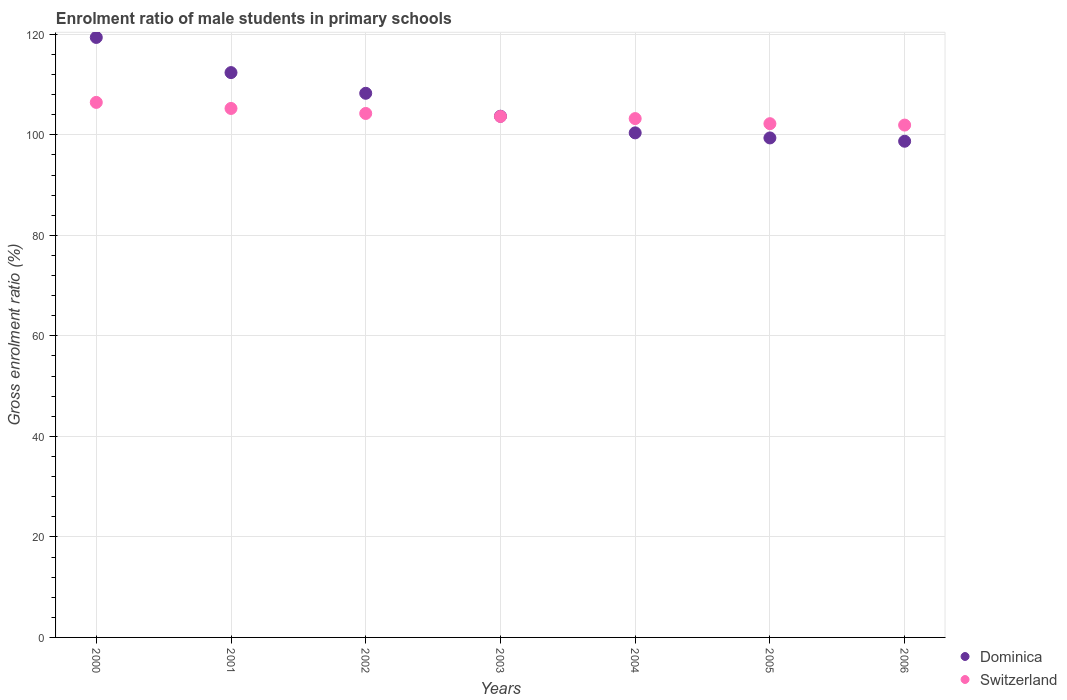How many different coloured dotlines are there?
Make the answer very short. 2. What is the enrolment ratio of male students in primary schools in Dominica in 2002?
Offer a very short reply. 108.27. Across all years, what is the maximum enrolment ratio of male students in primary schools in Dominica?
Make the answer very short. 119.38. Across all years, what is the minimum enrolment ratio of male students in primary schools in Switzerland?
Provide a short and direct response. 101.94. In which year was the enrolment ratio of male students in primary schools in Dominica minimum?
Ensure brevity in your answer.  2006. What is the total enrolment ratio of male students in primary schools in Switzerland in the graph?
Make the answer very short. 727.02. What is the difference between the enrolment ratio of male students in primary schools in Switzerland in 2001 and that in 2004?
Keep it short and to the point. 2.02. What is the difference between the enrolment ratio of male students in primary schools in Dominica in 2002 and the enrolment ratio of male students in primary schools in Switzerland in 2000?
Give a very brief answer. 1.81. What is the average enrolment ratio of male students in primary schools in Dominica per year?
Provide a succinct answer. 106.03. In the year 2003, what is the difference between the enrolment ratio of male students in primary schools in Dominica and enrolment ratio of male students in primary schools in Switzerland?
Provide a short and direct response. 0.04. In how many years, is the enrolment ratio of male students in primary schools in Dominica greater than 8 %?
Provide a succinct answer. 7. What is the ratio of the enrolment ratio of male students in primary schools in Switzerland in 2003 to that in 2004?
Offer a very short reply. 1. What is the difference between the highest and the second highest enrolment ratio of male students in primary schools in Dominica?
Offer a very short reply. 7. What is the difference between the highest and the lowest enrolment ratio of male students in primary schools in Dominica?
Give a very brief answer. 20.65. In how many years, is the enrolment ratio of male students in primary schools in Switzerland greater than the average enrolment ratio of male students in primary schools in Switzerland taken over all years?
Provide a short and direct response. 3. How many years are there in the graph?
Give a very brief answer. 7. Are the values on the major ticks of Y-axis written in scientific E-notation?
Ensure brevity in your answer.  No. Does the graph contain any zero values?
Your response must be concise. No. Where does the legend appear in the graph?
Your answer should be very brief. Bottom right. How many legend labels are there?
Give a very brief answer. 2. How are the legend labels stacked?
Provide a short and direct response. Vertical. What is the title of the graph?
Offer a very short reply. Enrolment ratio of male students in primary schools. What is the label or title of the Y-axis?
Provide a succinct answer. Gross enrolment ratio (%). What is the Gross enrolment ratio (%) in Dominica in 2000?
Provide a short and direct response. 119.38. What is the Gross enrolment ratio (%) of Switzerland in 2000?
Provide a short and direct response. 106.45. What is the Gross enrolment ratio (%) of Dominica in 2001?
Provide a succinct answer. 112.38. What is the Gross enrolment ratio (%) of Switzerland in 2001?
Make the answer very short. 105.25. What is the Gross enrolment ratio (%) in Dominica in 2002?
Keep it short and to the point. 108.27. What is the Gross enrolment ratio (%) in Switzerland in 2002?
Keep it short and to the point. 104.25. What is the Gross enrolment ratio (%) in Dominica in 2003?
Your response must be concise. 103.7. What is the Gross enrolment ratio (%) in Switzerland in 2003?
Your response must be concise. 103.66. What is the Gross enrolment ratio (%) of Dominica in 2004?
Provide a succinct answer. 100.39. What is the Gross enrolment ratio (%) of Switzerland in 2004?
Offer a terse response. 103.23. What is the Gross enrolment ratio (%) of Dominica in 2005?
Your response must be concise. 99.38. What is the Gross enrolment ratio (%) of Switzerland in 2005?
Offer a terse response. 102.22. What is the Gross enrolment ratio (%) in Dominica in 2006?
Your response must be concise. 98.73. What is the Gross enrolment ratio (%) in Switzerland in 2006?
Keep it short and to the point. 101.94. Across all years, what is the maximum Gross enrolment ratio (%) of Dominica?
Keep it short and to the point. 119.38. Across all years, what is the maximum Gross enrolment ratio (%) in Switzerland?
Your response must be concise. 106.45. Across all years, what is the minimum Gross enrolment ratio (%) of Dominica?
Provide a succinct answer. 98.73. Across all years, what is the minimum Gross enrolment ratio (%) in Switzerland?
Your answer should be very brief. 101.94. What is the total Gross enrolment ratio (%) of Dominica in the graph?
Your response must be concise. 742.24. What is the total Gross enrolment ratio (%) in Switzerland in the graph?
Provide a succinct answer. 727.02. What is the difference between the Gross enrolment ratio (%) of Dominica in 2000 and that in 2001?
Your answer should be very brief. 7. What is the difference between the Gross enrolment ratio (%) in Switzerland in 2000 and that in 2001?
Give a very brief answer. 1.2. What is the difference between the Gross enrolment ratio (%) in Dominica in 2000 and that in 2002?
Provide a succinct answer. 11.11. What is the difference between the Gross enrolment ratio (%) of Switzerland in 2000 and that in 2002?
Provide a succinct answer. 2.2. What is the difference between the Gross enrolment ratio (%) of Dominica in 2000 and that in 2003?
Ensure brevity in your answer.  15.68. What is the difference between the Gross enrolment ratio (%) in Switzerland in 2000 and that in 2003?
Your answer should be very brief. 2.8. What is the difference between the Gross enrolment ratio (%) of Dominica in 2000 and that in 2004?
Keep it short and to the point. 18.99. What is the difference between the Gross enrolment ratio (%) of Switzerland in 2000 and that in 2004?
Your answer should be compact. 3.22. What is the difference between the Gross enrolment ratio (%) in Dominica in 2000 and that in 2005?
Give a very brief answer. 20. What is the difference between the Gross enrolment ratio (%) in Switzerland in 2000 and that in 2005?
Make the answer very short. 4.23. What is the difference between the Gross enrolment ratio (%) of Dominica in 2000 and that in 2006?
Offer a very short reply. 20.65. What is the difference between the Gross enrolment ratio (%) in Switzerland in 2000 and that in 2006?
Ensure brevity in your answer.  4.51. What is the difference between the Gross enrolment ratio (%) of Dominica in 2001 and that in 2002?
Make the answer very short. 4.12. What is the difference between the Gross enrolment ratio (%) in Switzerland in 2001 and that in 2002?
Your answer should be compact. 1. What is the difference between the Gross enrolment ratio (%) in Dominica in 2001 and that in 2003?
Offer a terse response. 8.68. What is the difference between the Gross enrolment ratio (%) in Switzerland in 2001 and that in 2003?
Ensure brevity in your answer.  1.59. What is the difference between the Gross enrolment ratio (%) in Dominica in 2001 and that in 2004?
Ensure brevity in your answer.  11.99. What is the difference between the Gross enrolment ratio (%) of Switzerland in 2001 and that in 2004?
Give a very brief answer. 2.02. What is the difference between the Gross enrolment ratio (%) in Dominica in 2001 and that in 2005?
Offer a terse response. 13. What is the difference between the Gross enrolment ratio (%) of Switzerland in 2001 and that in 2005?
Your response must be concise. 3.03. What is the difference between the Gross enrolment ratio (%) in Dominica in 2001 and that in 2006?
Your answer should be compact. 13.66. What is the difference between the Gross enrolment ratio (%) in Switzerland in 2001 and that in 2006?
Offer a terse response. 3.31. What is the difference between the Gross enrolment ratio (%) in Dominica in 2002 and that in 2003?
Provide a succinct answer. 4.57. What is the difference between the Gross enrolment ratio (%) of Switzerland in 2002 and that in 2003?
Provide a succinct answer. 0.6. What is the difference between the Gross enrolment ratio (%) of Dominica in 2002 and that in 2004?
Your answer should be compact. 7.87. What is the difference between the Gross enrolment ratio (%) of Switzerland in 2002 and that in 2004?
Your response must be concise. 1.02. What is the difference between the Gross enrolment ratio (%) in Dominica in 2002 and that in 2005?
Provide a succinct answer. 8.88. What is the difference between the Gross enrolment ratio (%) in Switzerland in 2002 and that in 2005?
Make the answer very short. 2.03. What is the difference between the Gross enrolment ratio (%) in Dominica in 2002 and that in 2006?
Your answer should be very brief. 9.54. What is the difference between the Gross enrolment ratio (%) of Switzerland in 2002 and that in 2006?
Your response must be concise. 2.31. What is the difference between the Gross enrolment ratio (%) of Dominica in 2003 and that in 2004?
Your answer should be very brief. 3.31. What is the difference between the Gross enrolment ratio (%) of Switzerland in 2003 and that in 2004?
Keep it short and to the point. 0.42. What is the difference between the Gross enrolment ratio (%) of Dominica in 2003 and that in 2005?
Provide a short and direct response. 4.32. What is the difference between the Gross enrolment ratio (%) in Switzerland in 2003 and that in 2005?
Provide a succinct answer. 1.44. What is the difference between the Gross enrolment ratio (%) in Dominica in 2003 and that in 2006?
Make the answer very short. 4.97. What is the difference between the Gross enrolment ratio (%) of Switzerland in 2003 and that in 2006?
Ensure brevity in your answer.  1.72. What is the difference between the Gross enrolment ratio (%) of Dominica in 2004 and that in 2005?
Give a very brief answer. 1.01. What is the difference between the Gross enrolment ratio (%) in Switzerland in 2004 and that in 2005?
Give a very brief answer. 1.01. What is the difference between the Gross enrolment ratio (%) of Dominica in 2004 and that in 2006?
Offer a very short reply. 1.67. What is the difference between the Gross enrolment ratio (%) in Switzerland in 2004 and that in 2006?
Provide a succinct answer. 1.29. What is the difference between the Gross enrolment ratio (%) in Dominica in 2005 and that in 2006?
Ensure brevity in your answer.  0.66. What is the difference between the Gross enrolment ratio (%) in Switzerland in 2005 and that in 2006?
Offer a terse response. 0.28. What is the difference between the Gross enrolment ratio (%) in Dominica in 2000 and the Gross enrolment ratio (%) in Switzerland in 2001?
Your answer should be compact. 14.13. What is the difference between the Gross enrolment ratio (%) in Dominica in 2000 and the Gross enrolment ratio (%) in Switzerland in 2002?
Your answer should be compact. 15.13. What is the difference between the Gross enrolment ratio (%) in Dominica in 2000 and the Gross enrolment ratio (%) in Switzerland in 2003?
Provide a succinct answer. 15.72. What is the difference between the Gross enrolment ratio (%) in Dominica in 2000 and the Gross enrolment ratio (%) in Switzerland in 2004?
Offer a very short reply. 16.15. What is the difference between the Gross enrolment ratio (%) of Dominica in 2000 and the Gross enrolment ratio (%) of Switzerland in 2005?
Your answer should be compact. 17.16. What is the difference between the Gross enrolment ratio (%) of Dominica in 2000 and the Gross enrolment ratio (%) of Switzerland in 2006?
Your answer should be compact. 17.44. What is the difference between the Gross enrolment ratio (%) in Dominica in 2001 and the Gross enrolment ratio (%) in Switzerland in 2002?
Keep it short and to the point. 8.13. What is the difference between the Gross enrolment ratio (%) in Dominica in 2001 and the Gross enrolment ratio (%) in Switzerland in 2003?
Your response must be concise. 8.73. What is the difference between the Gross enrolment ratio (%) of Dominica in 2001 and the Gross enrolment ratio (%) of Switzerland in 2004?
Offer a terse response. 9.15. What is the difference between the Gross enrolment ratio (%) of Dominica in 2001 and the Gross enrolment ratio (%) of Switzerland in 2005?
Your answer should be very brief. 10.16. What is the difference between the Gross enrolment ratio (%) in Dominica in 2001 and the Gross enrolment ratio (%) in Switzerland in 2006?
Offer a terse response. 10.44. What is the difference between the Gross enrolment ratio (%) in Dominica in 2002 and the Gross enrolment ratio (%) in Switzerland in 2003?
Keep it short and to the point. 4.61. What is the difference between the Gross enrolment ratio (%) of Dominica in 2002 and the Gross enrolment ratio (%) of Switzerland in 2004?
Offer a terse response. 5.03. What is the difference between the Gross enrolment ratio (%) of Dominica in 2002 and the Gross enrolment ratio (%) of Switzerland in 2005?
Your answer should be compact. 6.05. What is the difference between the Gross enrolment ratio (%) of Dominica in 2002 and the Gross enrolment ratio (%) of Switzerland in 2006?
Ensure brevity in your answer.  6.33. What is the difference between the Gross enrolment ratio (%) in Dominica in 2003 and the Gross enrolment ratio (%) in Switzerland in 2004?
Provide a short and direct response. 0.47. What is the difference between the Gross enrolment ratio (%) in Dominica in 2003 and the Gross enrolment ratio (%) in Switzerland in 2005?
Give a very brief answer. 1.48. What is the difference between the Gross enrolment ratio (%) of Dominica in 2003 and the Gross enrolment ratio (%) of Switzerland in 2006?
Provide a short and direct response. 1.76. What is the difference between the Gross enrolment ratio (%) of Dominica in 2004 and the Gross enrolment ratio (%) of Switzerland in 2005?
Keep it short and to the point. -1.83. What is the difference between the Gross enrolment ratio (%) of Dominica in 2004 and the Gross enrolment ratio (%) of Switzerland in 2006?
Make the answer very short. -1.55. What is the difference between the Gross enrolment ratio (%) in Dominica in 2005 and the Gross enrolment ratio (%) in Switzerland in 2006?
Give a very brief answer. -2.56. What is the average Gross enrolment ratio (%) of Dominica per year?
Make the answer very short. 106.03. What is the average Gross enrolment ratio (%) of Switzerland per year?
Provide a short and direct response. 103.86. In the year 2000, what is the difference between the Gross enrolment ratio (%) in Dominica and Gross enrolment ratio (%) in Switzerland?
Offer a very short reply. 12.93. In the year 2001, what is the difference between the Gross enrolment ratio (%) of Dominica and Gross enrolment ratio (%) of Switzerland?
Your answer should be very brief. 7.13. In the year 2002, what is the difference between the Gross enrolment ratio (%) of Dominica and Gross enrolment ratio (%) of Switzerland?
Your answer should be very brief. 4.01. In the year 2003, what is the difference between the Gross enrolment ratio (%) of Dominica and Gross enrolment ratio (%) of Switzerland?
Offer a terse response. 0.04. In the year 2004, what is the difference between the Gross enrolment ratio (%) of Dominica and Gross enrolment ratio (%) of Switzerland?
Give a very brief answer. -2.84. In the year 2005, what is the difference between the Gross enrolment ratio (%) of Dominica and Gross enrolment ratio (%) of Switzerland?
Give a very brief answer. -2.84. In the year 2006, what is the difference between the Gross enrolment ratio (%) of Dominica and Gross enrolment ratio (%) of Switzerland?
Your answer should be compact. -3.22. What is the ratio of the Gross enrolment ratio (%) of Dominica in 2000 to that in 2001?
Your answer should be very brief. 1.06. What is the ratio of the Gross enrolment ratio (%) of Switzerland in 2000 to that in 2001?
Your answer should be very brief. 1.01. What is the ratio of the Gross enrolment ratio (%) of Dominica in 2000 to that in 2002?
Ensure brevity in your answer.  1.1. What is the ratio of the Gross enrolment ratio (%) of Switzerland in 2000 to that in 2002?
Give a very brief answer. 1.02. What is the ratio of the Gross enrolment ratio (%) in Dominica in 2000 to that in 2003?
Offer a terse response. 1.15. What is the ratio of the Gross enrolment ratio (%) of Dominica in 2000 to that in 2004?
Ensure brevity in your answer.  1.19. What is the ratio of the Gross enrolment ratio (%) in Switzerland in 2000 to that in 2004?
Provide a short and direct response. 1.03. What is the ratio of the Gross enrolment ratio (%) of Dominica in 2000 to that in 2005?
Offer a very short reply. 1.2. What is the ratio of the Gross enrolment ratio (%) in Switzerland in 2000 to that in 2005?
Offer a terse response. 1.04. What is the ratio of the Gross enrolment ratio (%) of Dominica in 2000 to that in 2006?
Your answer should be compact. 1.21. What is the ratio of the Gross enrolment ratio (%) of Switzerland in 2000 to that in 2006?
Offer a terse response. 1.04. What is the ratio of the Gross enrolment ratio (%) in Dominica in 2001 to that in 2002?
Offer a terse response. 1.04. What is the ratio of the Gross enrolment ratio (%) of Switzerland in 2001 to that in 2002?
Give a very brief answer. 1.01. What is the ratio of the Gross enrolment ratio (%) of Dominica in 2001 to that in 2003?
Offer a very short reply. 1.08. What is the ratio of the Gross enrolment ratio (%) in Switzerland in 2001 to that in 2003?
Offer a very short reply. 1.02. What is the ratio of the Gross enrolment ratio (%) in Dominica in 2001 to that in 2004?
Your response must be concise. 1.12. What is the ratio of the Gross enrolment ratio (%) in Switzerland in 2001 to that in 2004?
Make the answer very short. 1.02. What is the ratio of the Gross enrolment ratio (%) of Dominica in 2001 to that in 2005?
Your response must be concise. 1.13. What is the ratio of the Gross enrolment ratio (%) of Switzerland in 2001 to that in 2005?
Give a very brief answer. 1.03. What is the ratio of the Gross enrolment ratio (%) of Dominica in 2001 to that in 2006?
Your answer should be compact. 1.14. What is the ratio of the Gross enrolment ratio (%) of Switzerland in 2001 to that in 2006?
Make the answer very short. 1.03. What is the ratio of the Gross enrolment ratio (%) in Dominica in 2002 to that in 2003?
Offer a terse response. 1.04. What is the ratio of the Gross enrolment ratio (%) in Switzerland in 2002 to that in 2003?
Provide a short and direct response. 1.01. What is the ratio of the Gross enrolment ratio (%) in Dominica in 2002 to that in 2004?
Your response must be concise. 1.08. What is the ratio of the Gross enrolment ratio (%) of Switzerland in 2002 to that in 2004?
Provide a short and direct response. 1.01. What is the ratio of the Gross enrolment ratio (%) in Dominica in 2002 to that in 2005?
Make the answer very short. 1.09. What is the ratio of the Gross enrolment ratio (%) of Switzerland in 2002 to that in 2005?
Offer a terse response. 1.02. What is the ratio of the Gross enrolment ratio (%) in Dominica in 2002 to that in 2006?
Provide a succinct answer. 1.1. What is the ratio of the Gross enrolment ratio (%) in Switzerland in 2002 to that in 2006?
Your answer should be very brief. 1.02. What is the ratio of the Gross enrolment ratio (%) in Dominica in 2003 to that in 2004?
Keep it short and to the point. 1.03. What is the ratio of the Gross enrolment ratio (%) of Switzerland in 2003 to that in 2004?
Give a very brief answer. 1. What is the ratio of the Gross enrolment ratio (%) in Dominica in 2003 to that in 2005?
Make the answer very short. 1.04. What is the ratio of the Gross enrolment ratio (%) of Switzerland in 2003 to that in 2005?
Provide a short and direct response. 1.01. What is the ratio of the Gross enrolment ratio (%) in Dominica in 2003 to that in 2006?
Offer a very short reply. 1.05. What is the ratio of the Gross enrolment ratio (%) of Switzerland in 2003 to that in 2006?
Your response must be concise. 1.02. What is the ratio of the Gross enrolment ratio (%) of Dominica in 2004 to that in 2005?
Ensure brevity in your answer.  1.01. What is the ratio of the Gross enrolment ratio (%) in Switzerland in 2004 to that in 2005?
Ensure brevity in your answer.  1.01. What is the ratio of the Gross enrolment ratio (%) in Dominica in 2004 to that in 2006?
Keep it short and to the point. 1.02. What is the ratio of the Gross enrolment ratio (%) of Switzerland in 2004 to that in 2006?
Give a very brief answer. 1.01. What is the ratio of the Gross enrolment ratio (%) in Dominica in 2005 to that in 2006?
Provide a succinct answer. 1.01. What is the difference between the highest and the second highest Gross enrolment ratio (%) in Dominica?
Offer a terse response. 7. What is the difference between the highest and the second highest Gross enrolment ratio (%) of Switzerland?
Provide a short and direct response. 1.2. What is the difference between the highest and the lowest Gross enrolment ratio (%) of Dominica?
Keep it short and to the point. 20.65. What is the difference between the highest and the lowest Gross enrolment ratio (%) of Switzerland?
Ensure brevity in your answer.  4.51. 